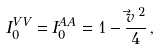<formula> <loc_0><loc_0><loc_500><loc_500>I _ { 0 } ^ { V V } = I _ { 0 } ^ { A A } = 1 - \frac { \vec { v } \, ^ { 2 } } { 4 } \, ,</formula> 